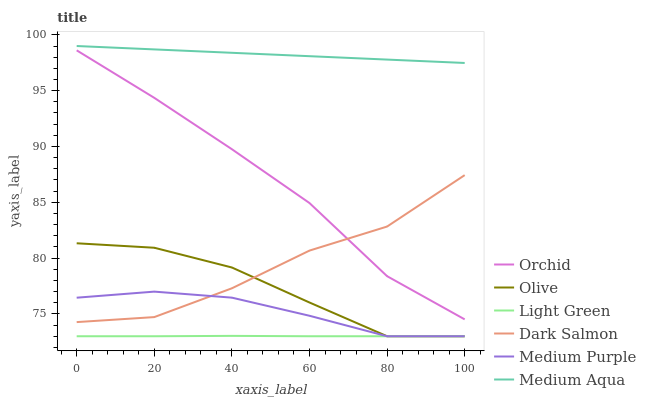Does Light Green have the minimum area under the curve?
Answer yes or no. Yes. Does Medium Aqua have the maximum area under the curve?
Answer yes or no. Yes. Does Medium Purple have the minimum area under the curve?
Answer yes or no. No. Does Medium Purple have the maximum area under the curve?
Answer yes or no. No. Is Medium Aqua the smoothest?
Answer yes or no. Yes. Is Dark Salmon the roughest?
Answer yes or no. Yes. Is Medium Purple the smoothest?
Answer yes or no. No. Is Medium Purple the roughest?
Answer yes or no. No. Does Medium Purple have the lowest value?
Answer yes or no. Yes. Does Medium Aqua have the lowest value?
Answer yes or no. No. Does Medium Aqua have the highest value?
Answer yes or no. Yes. Does Medium Purple have the highest value?
Answer yes or no. No. Is Light Green less than Orchid?
Answer yes or no. Yes. Is Orchid greater than Olive?
Answer yes or no. Yes. Does Olive intersect Medium Purple?
Answer yes or no. Yes. Is Olive less than Medium Purple?
Answer yes or no. No. Is Olive greater than Medium Purple?
Answer yes or no. No. Does Light Green intersect Orchid?
Answer yes or no. No. 